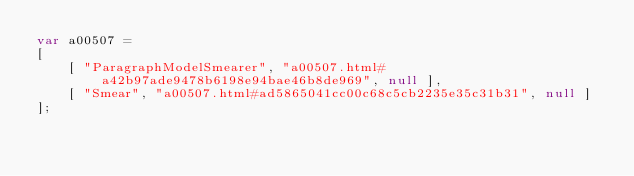Convert code to text. <code><loc_0><loc_0><loc_500><loc_500><_JavaScript_>var a00507 =
[
    [ "ParagraphModelSmearer", "a00507.html#a42b97ade9478b6198e94bae46b8de969", null ],
    [ "Smear", "a00507.html#ad5865041cc00c68c5cb2235e35c31b31", null ]
];</code> 